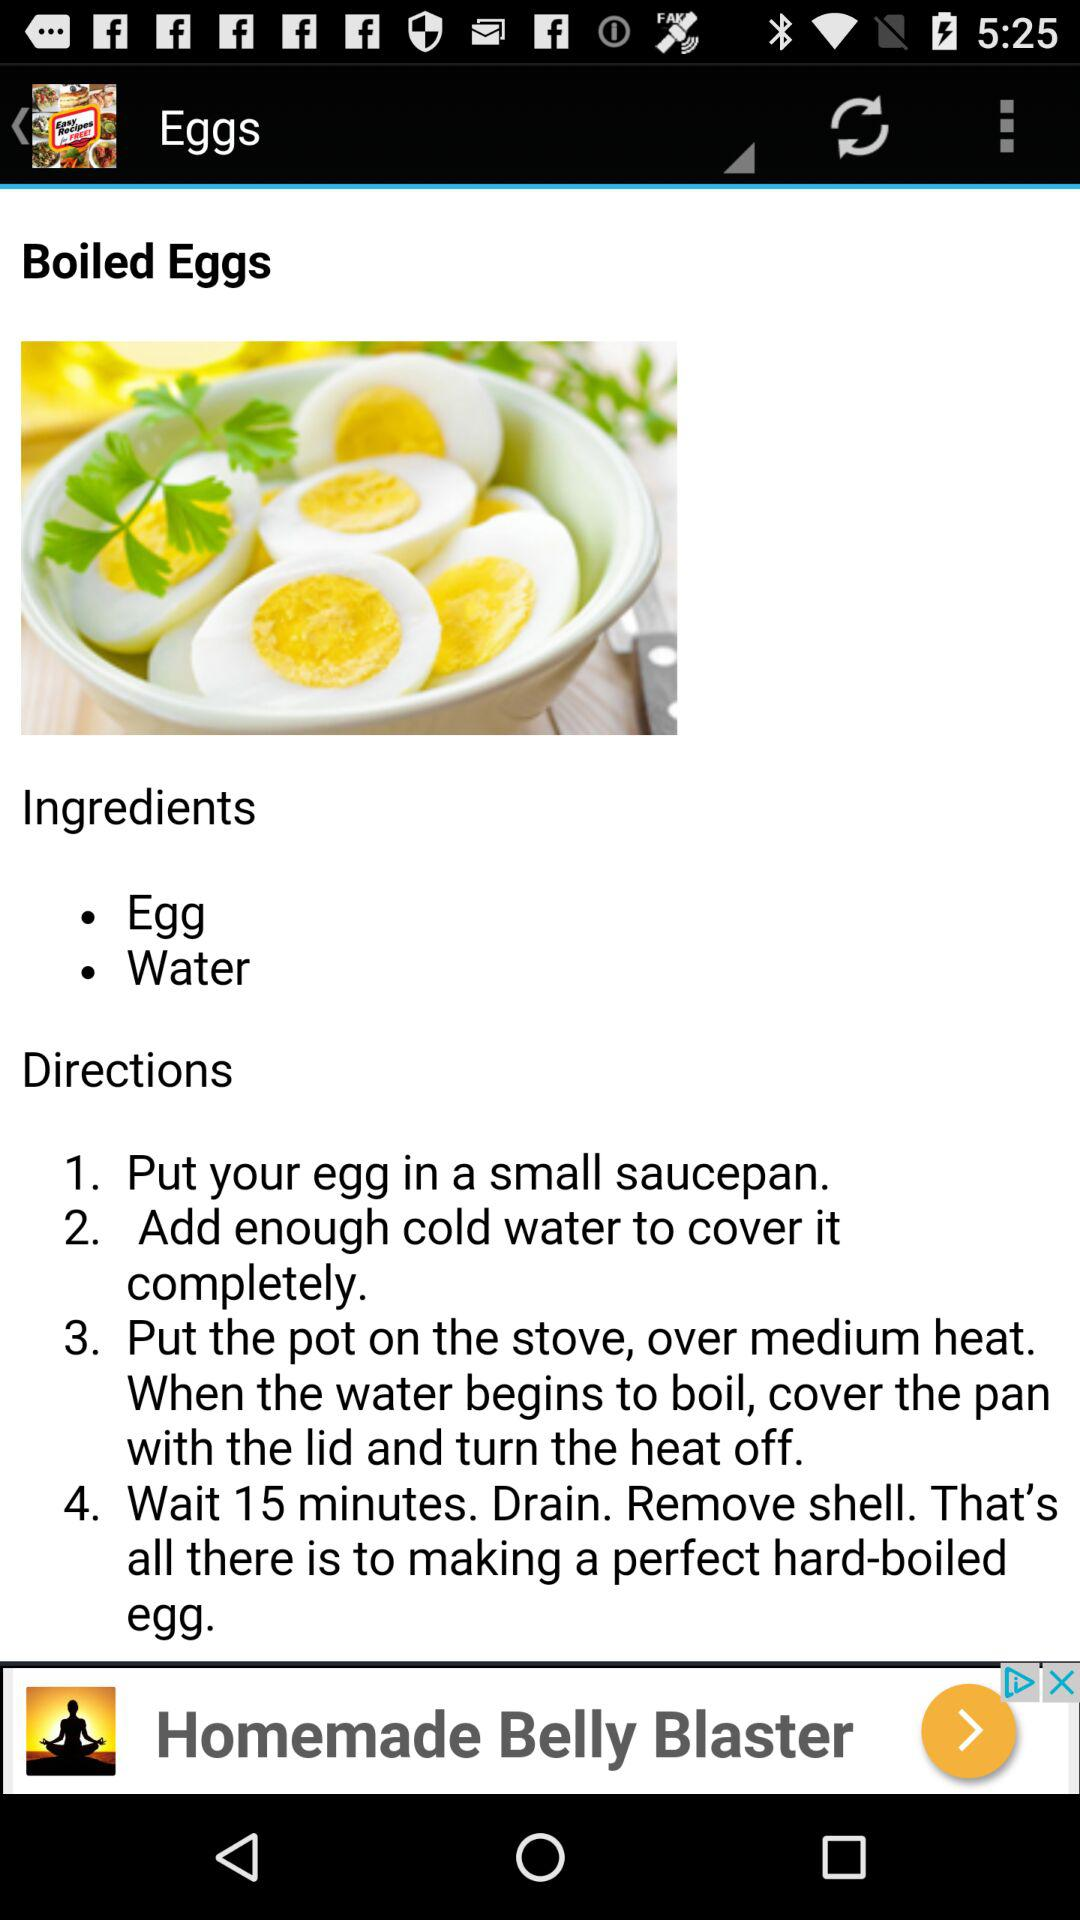What are the ingredients? The ingredients are eggs and water. 